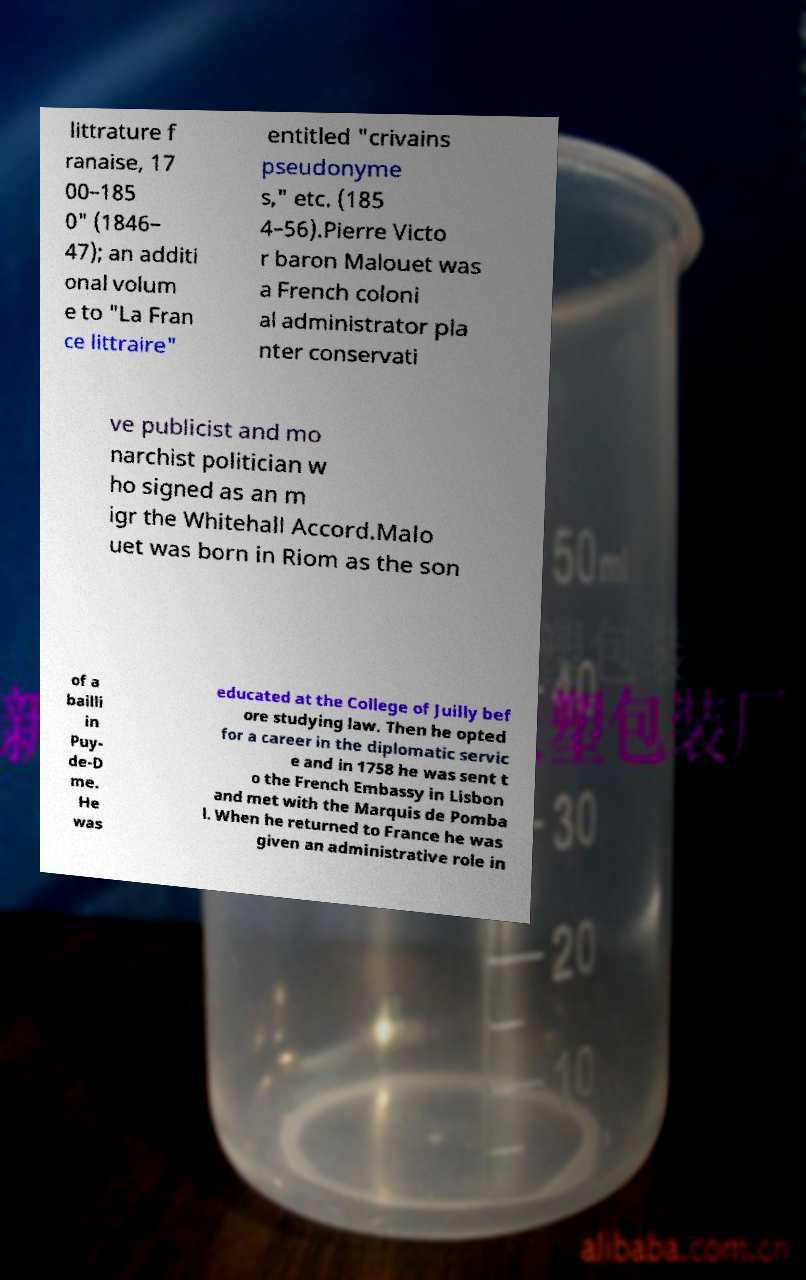I need the written content from this picture converted into text. Can you do that? littrature f ranaise, 17 00–185 0" (1846– 47); an additi onal volum e to "La Fran ce littraire" entitled "crivains pseudonyme s," etc. (185 4–56).Pierre Victo r baron Malouet was a French coloni al administrator pla nter conservati ve publicist and mo narchist politician w ho signed as an m igr the Whitehall Accord.Malo uet was born in Riom as the son of a bailli in Puy- de-D me. He was educated at the College of Juilly bef ore studying law. Then he opted for a career in the diplomatic servic e and in 1758 he was sent t o the French Embassy in Lisbon and met with the Marquis de Pomba l. When he returned to France he was given an administrative role in 